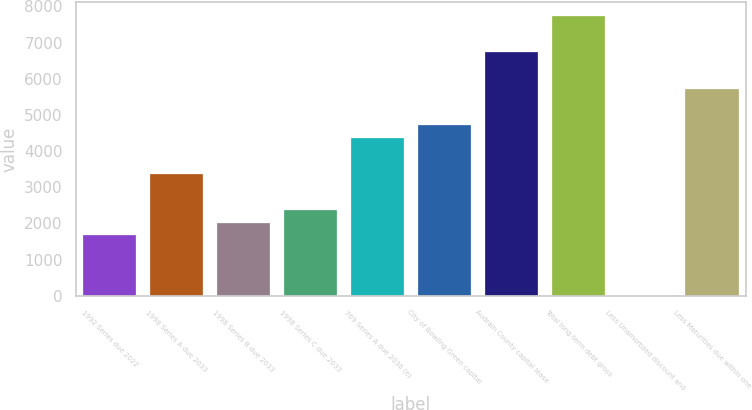Convert chart. <chart><loc_0><loc_0><loc_500><loc_500><bar_chart><fcel>1992 Series due 2022<fcel>1998 Series A due 2033<fcel>1998 Series B due 2033<fcel>1998 Series C due 2033<fcel>769 Series A due 2036 (e)<fcel>City of Bowling Green capital<fcel>Audrain County capital lease<fcel>Total long-term debt gross<fcel>Less Unamortized discount and<fcel>Less Maturities due within one<nl><fcel>1686<fcel>3366<fcel>2022<fcel>2358<fcel>4374<fcel>4710<fcel>6726<fcel>7734<fcel>6<fcel>5718<nl></chart> 